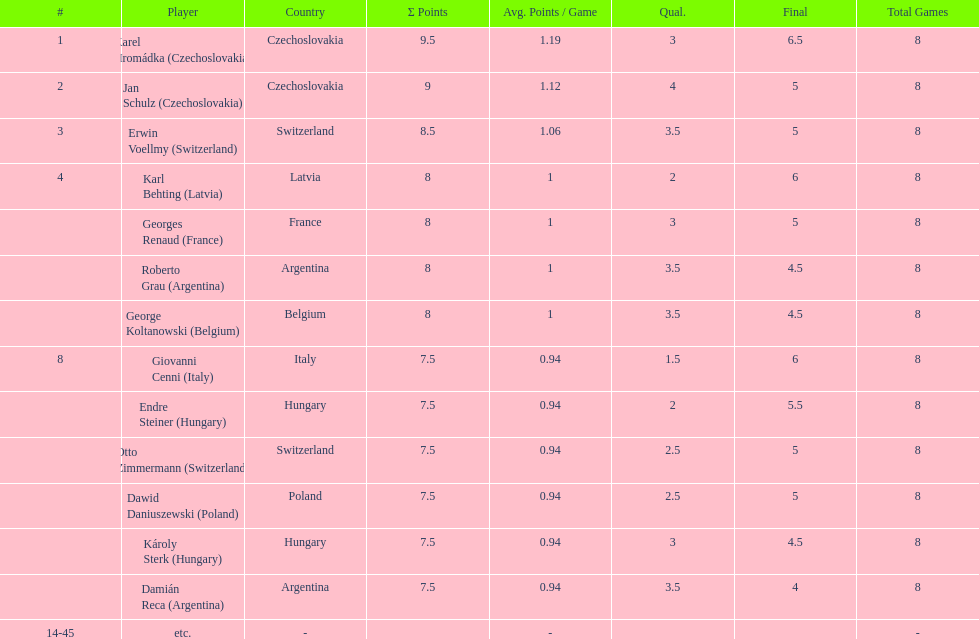The most points were scored by which player? Karel Hromádka. 